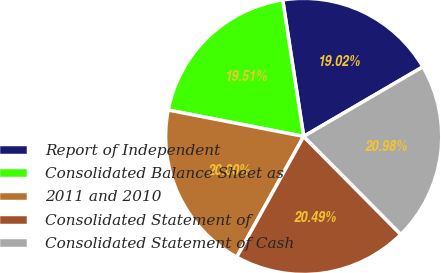<chart> <loc_0><loc_0><loc_500><loc_500><pie_chart><fcel>Report of Independent<fcel>Consolidated Balance Sheet as<fcel>2011 and 2010<fcel>Consolidated Statement of<fcel>Consolidated Statement of Cash<nl><fcel>19.02%<fcel>19.51%<fcel>20.0%<fcel>20.49%<fcel>20.98%<nl></chart> 